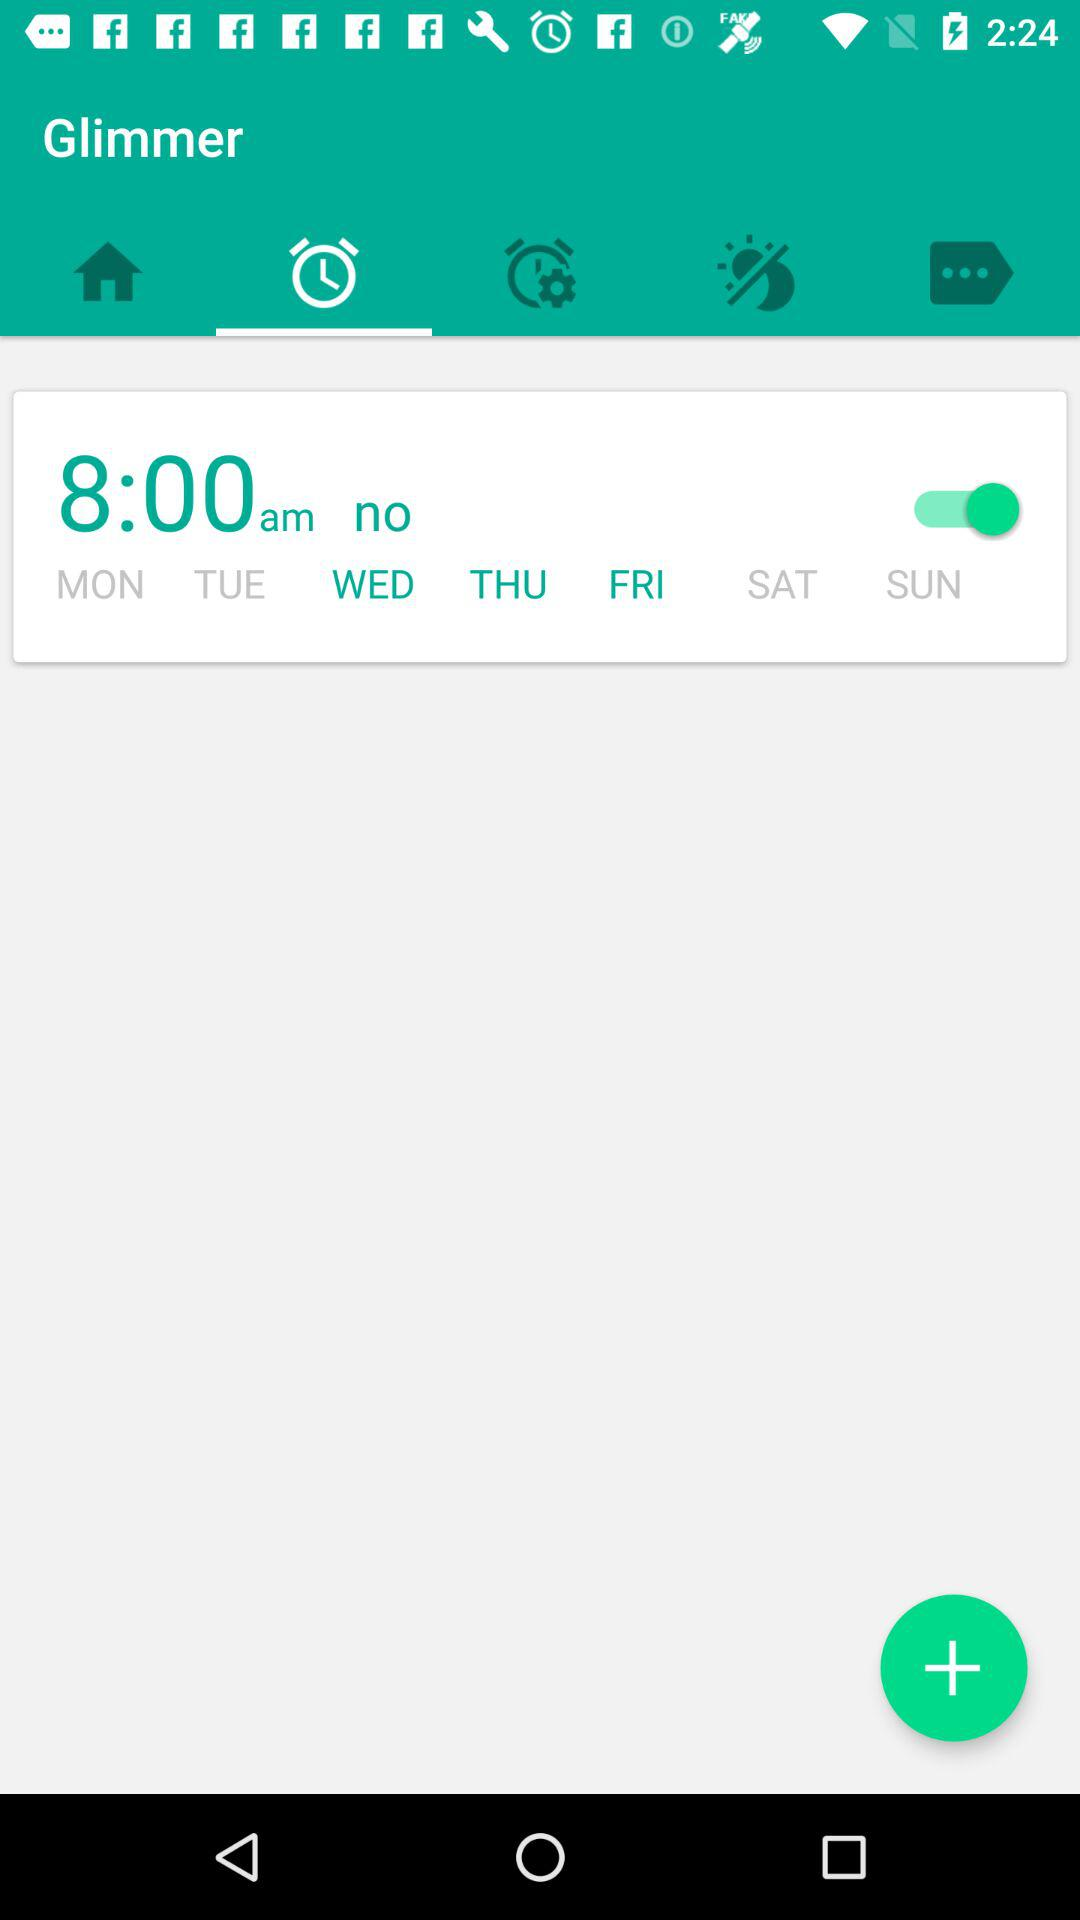What are the selected days? The selected days are "WED", "THU" and "FRI". 